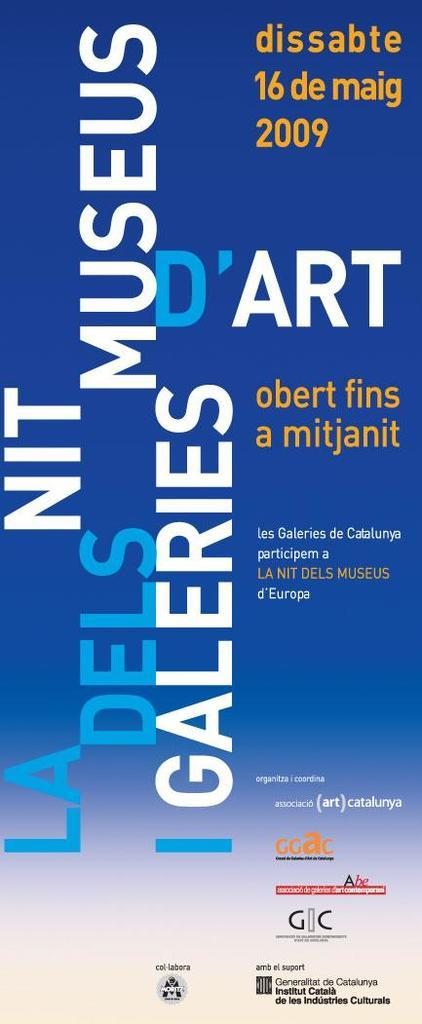<image>
Write a terse but informative summary of the picture. The poster advertises an art event that happened in May of 2009. 